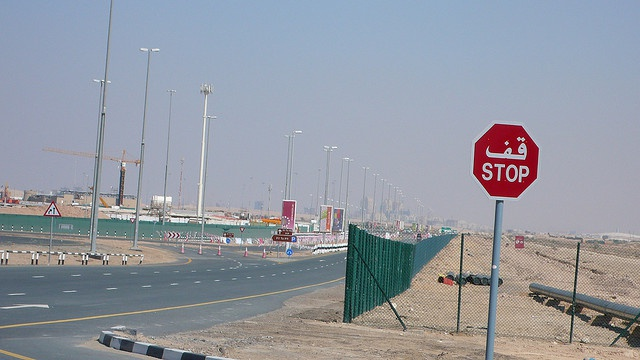Describe the objects in this image and their specific colors. I can see a stop sign in darkgray and maroon tones in this image. 